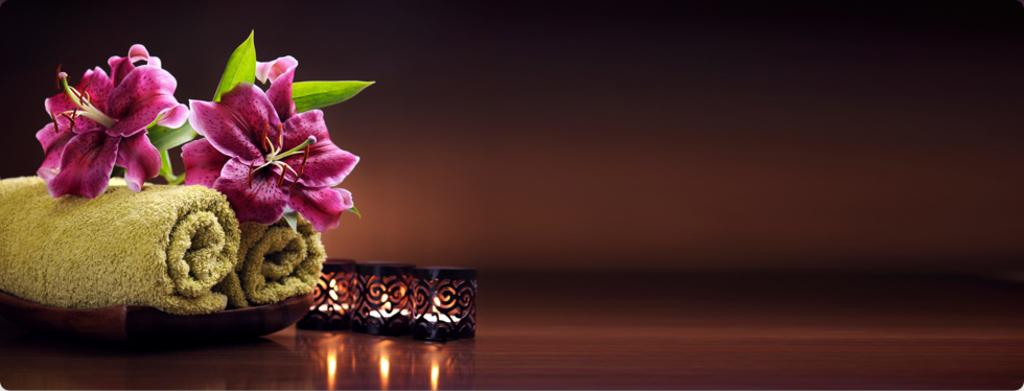What can be found on the left side of the image? There are flowers and a plate with napkins on the left side of the image. What is located beside the plate? There are lights beside the plate. What type of band is performing in the image? There is no band present in the image. What kind of art can be seen on the flowers in the image? The flowers themselves are not art, but they may be part of an artistic arrangement. However, there is no specific art mentioned or visible on the flowers in the image. 